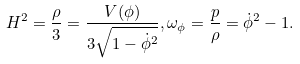Convert formula to latex. <formula><loc_0><loc_0><loc_500><loc_500>H ^ { 2 } = \frac { \rho } { 3 } = \frac { V ( \phi ) } { 3 \sqrt { 1 - \dot { \phi } ^ { 2 } } } , \omega _ { \phi } = \frac { p } { \rho } = \dot { \phi } ^ { 2 } - 1 .</formula> 